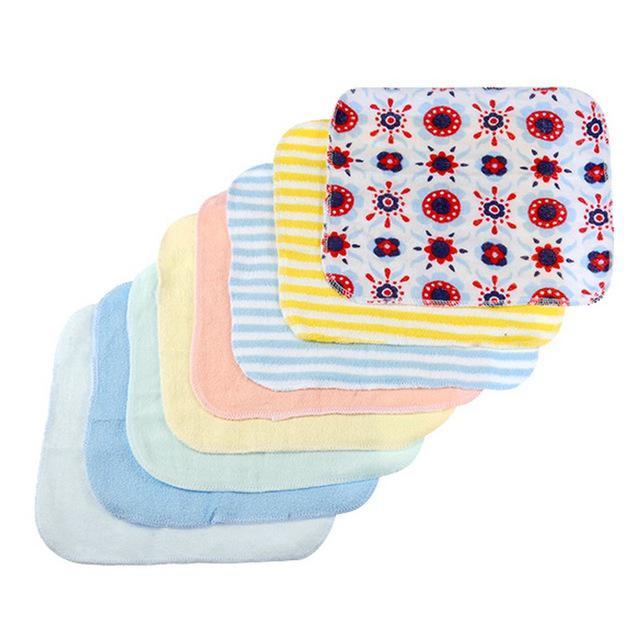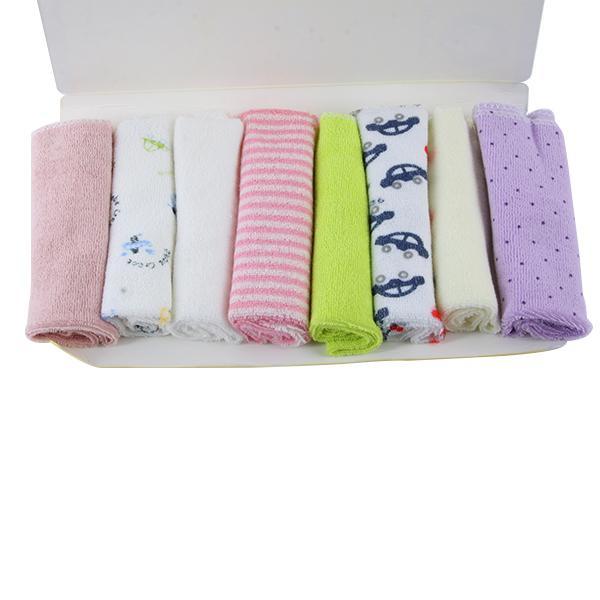The first image is the image on the left, the second image is the image on the right. Analyze the images presented: Is the assertion "There are exactly eight rolled towels." valid? Answer yes or no. Yes. The first image is the image on the left, the second image is the image on the right. Examine the images to the left and right. Is the description "Each image includes at least one row of folded cloth items, and one image features a package of eight rolled towels." accurate? Answer yes or no. No. 